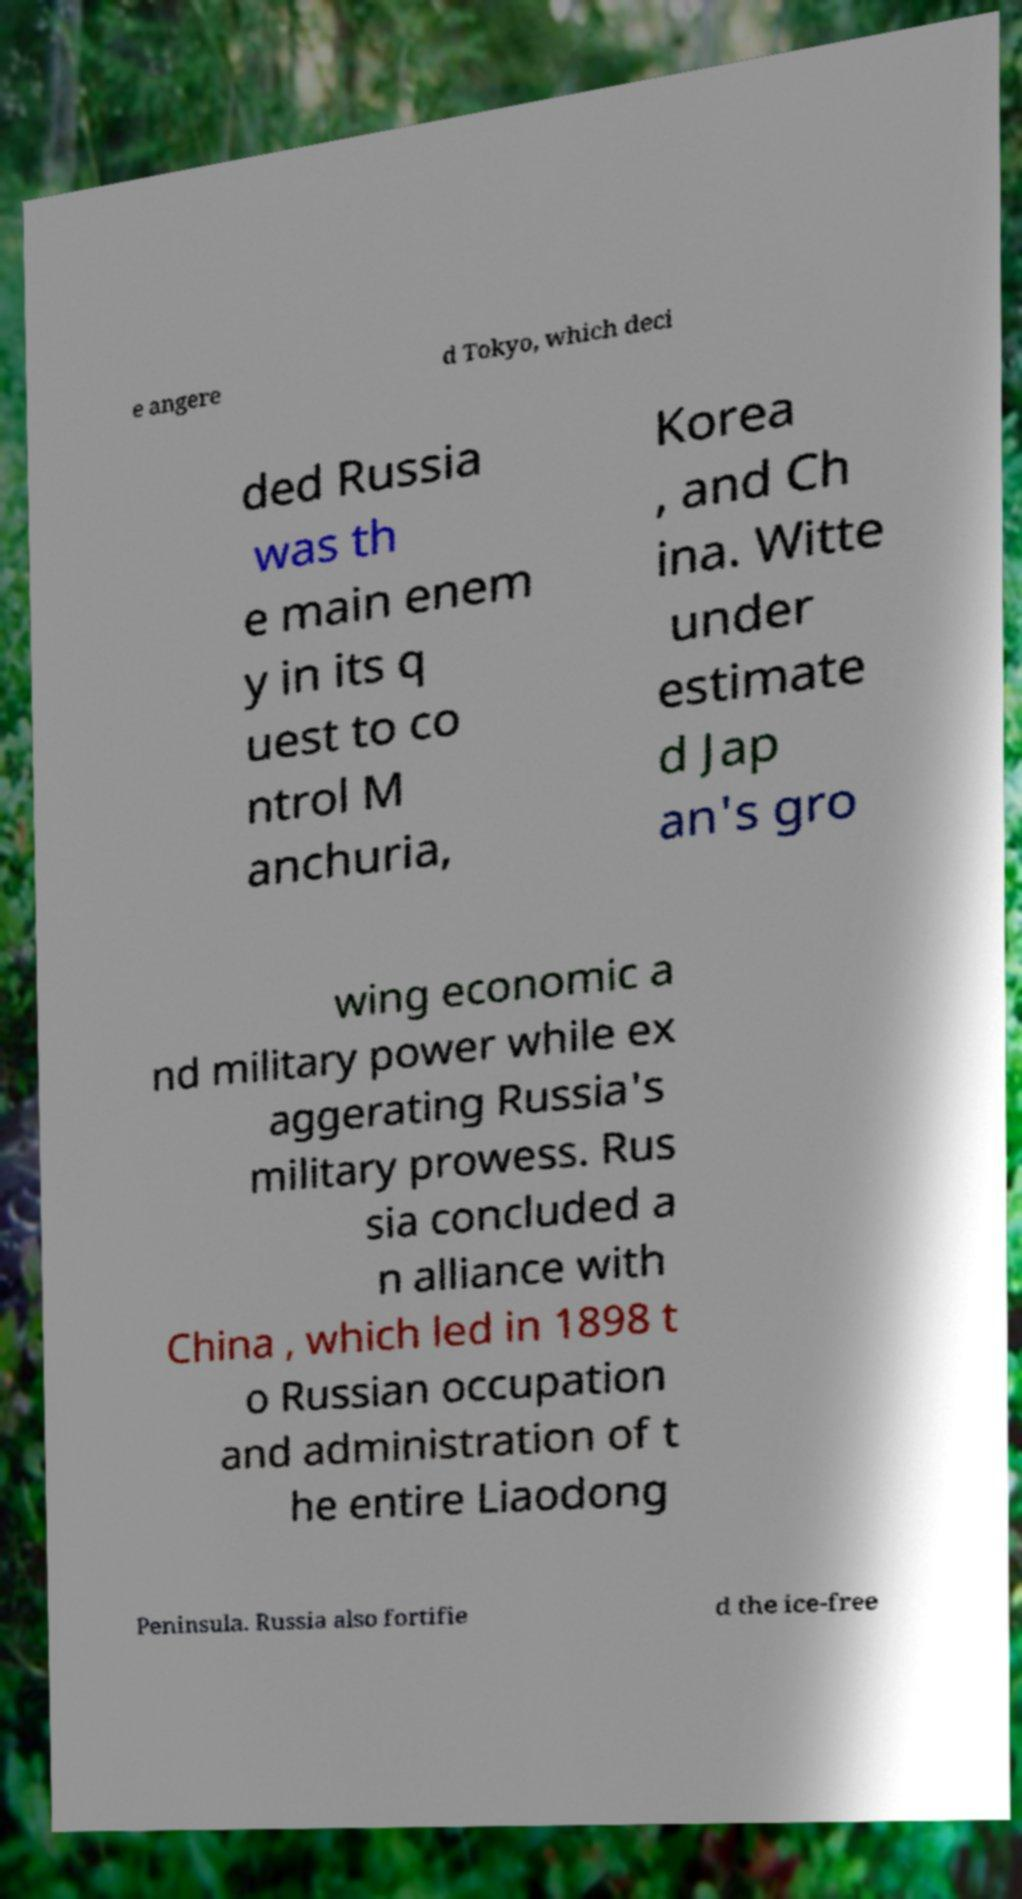I need the written content from this picture converted into text. Can you do that? e angere d Tokyo, which deci ded Russia was th e main enem y in its q uest to co ntrol M anchuria, Korea , and Ch ina. Witte under estimate d Jap an's gro wing economic a nd military power while ex aggerating Russia's military prowess. Rus sia concluded a n alliance with China , which led in 1898 t o Russian occupation and administration of t he entire Liaodong Peninsula. Russia also fortifie d the ice-free 